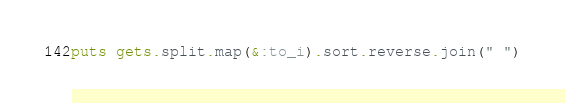<code> <loc_0><loc_0><loc_500><loc_500><_Ruby_>puts gets.split.map(&:to_i).sort.reverse.join(" ")</code> 